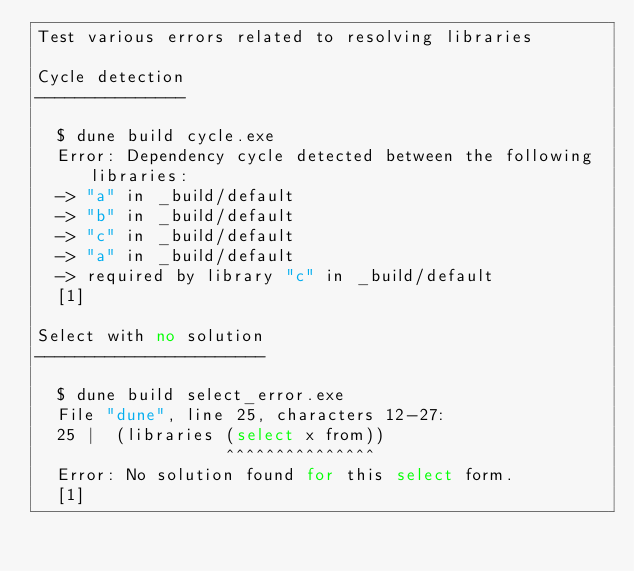<code> <loc_0><loc_0><loc_500><loc_500><_Perl_>Test various errors related to resolving libraries

Cycle detection
---------------

  $ dune build cycle.exe
  Error: Dependency cycle detected between the following libraries:
  -> "a" in _build/default
  -> "b" in _build/default
  -> "c" in _build/default
  -> "a" in _build/default
  -> required by library "c" in _build/default
  [1]

Select with no solution
-----------------------

  $ dune build select_error.exe
  File "dune", line 25, characters 12-27:
  25 |  (libraries (select x from))
                   ^^^^^^^^^^^^^^^
  Error: No solution found for this select form.
  [1]

</code> 